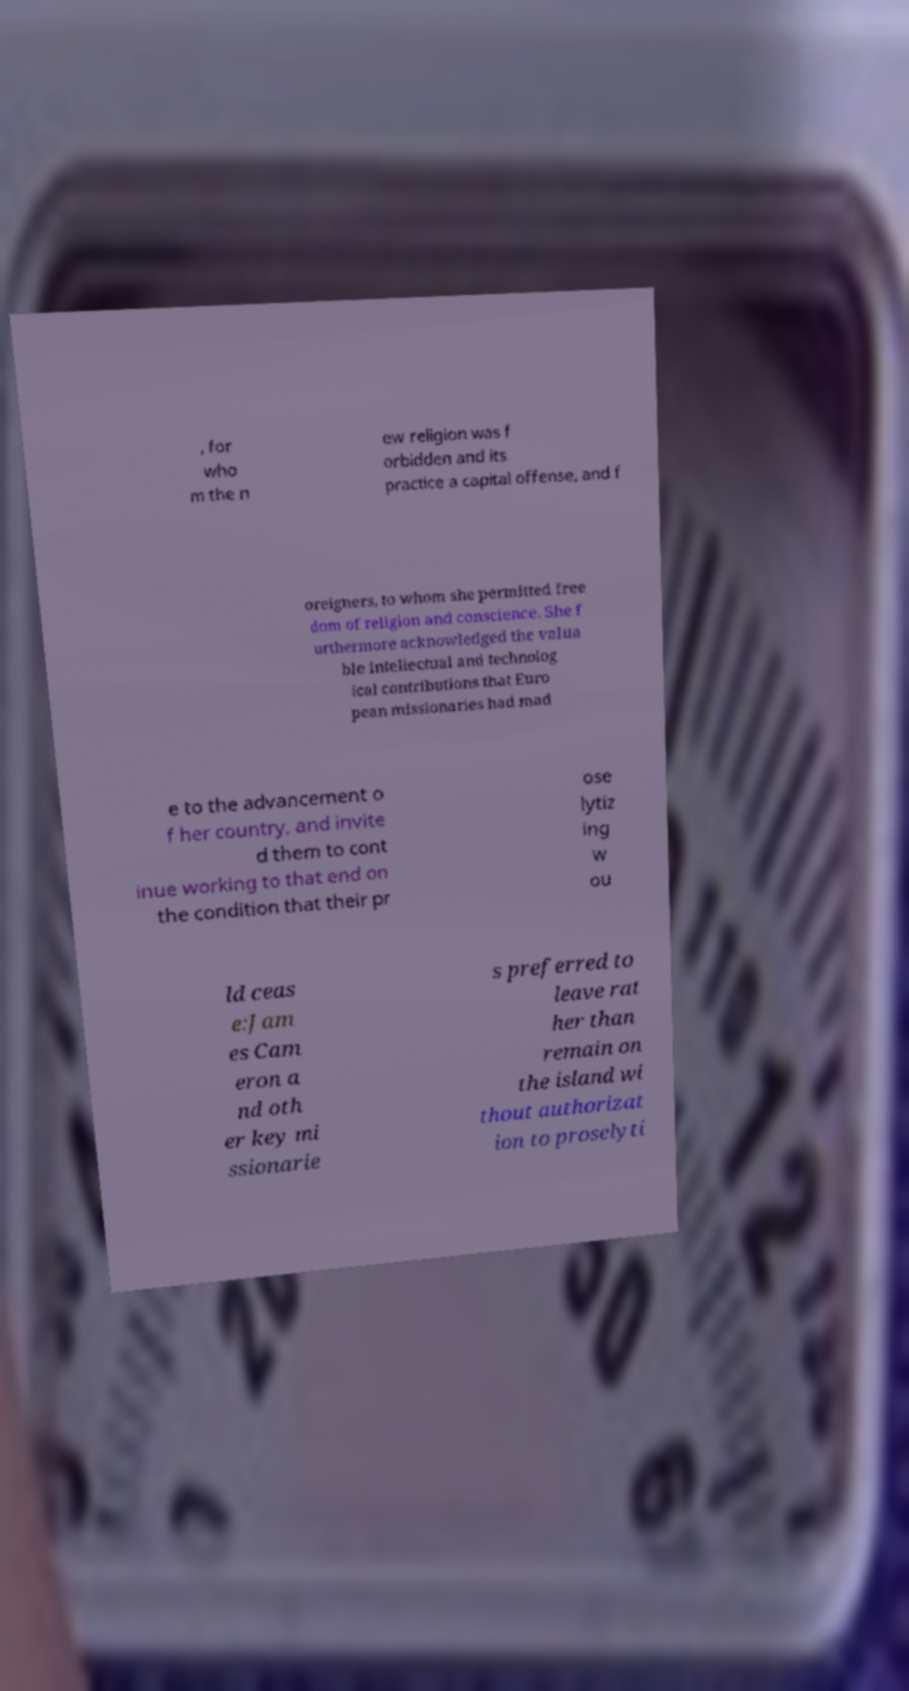Could you assist in decoding the text presented in this image and type it out clearly? , for who m the n ew religion was f orbidden and its practice a capital offense, and f oreigners, to whom she permitted free dom of religion and conscience. She f urthermore acknowledged the valua ble intellectual and technolog ical contributions that Euro pean missionaries had mad e to the advancement o f her country, and invite d them to cont inue working to that end on the condition that their pr ose lytiz ing w ou ld ceas e:Jam es Cam eron a nd oth er key mi ssionarie s preferred to leave rat her than remain on the island wi thout authorizat ion to proselyti 